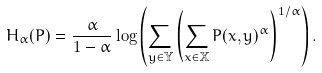Convert formula to latex. <formula><loc_0><loc_0><loc_500><loc_500>H _ { \alpha } ( P ) = \frac { \alpha } { 1 - \alpha } \log \left ( \sum _ { y \in \mathbb { Y } } \left ( \sum _ { x \in { \mathbb { X } } } P ( x , y ) ^ { \alpha } \right ) ^ { 1 / \alpha } \right ) .</formula> 